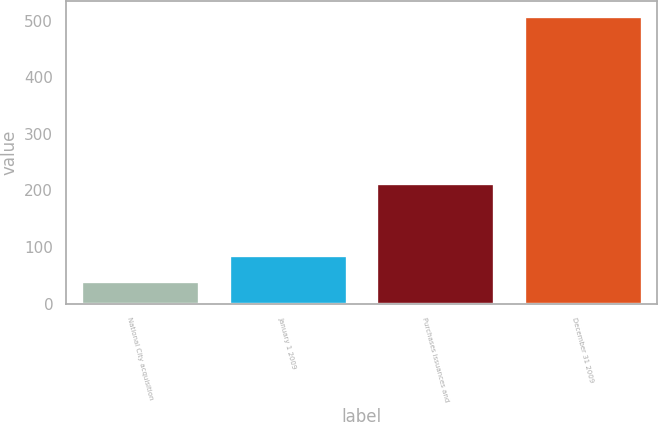Convert chart. <chart><loc_0><loc_0><loc_500><loc_500><bar_chart><fcel>National City acquisition<fcel>January 1 2009<fcel>Purchases issuances and<fcel>December 31 2009<nl><fcel>40<fcel>86.9<fcel>213<fcel>509<nl></chart> 